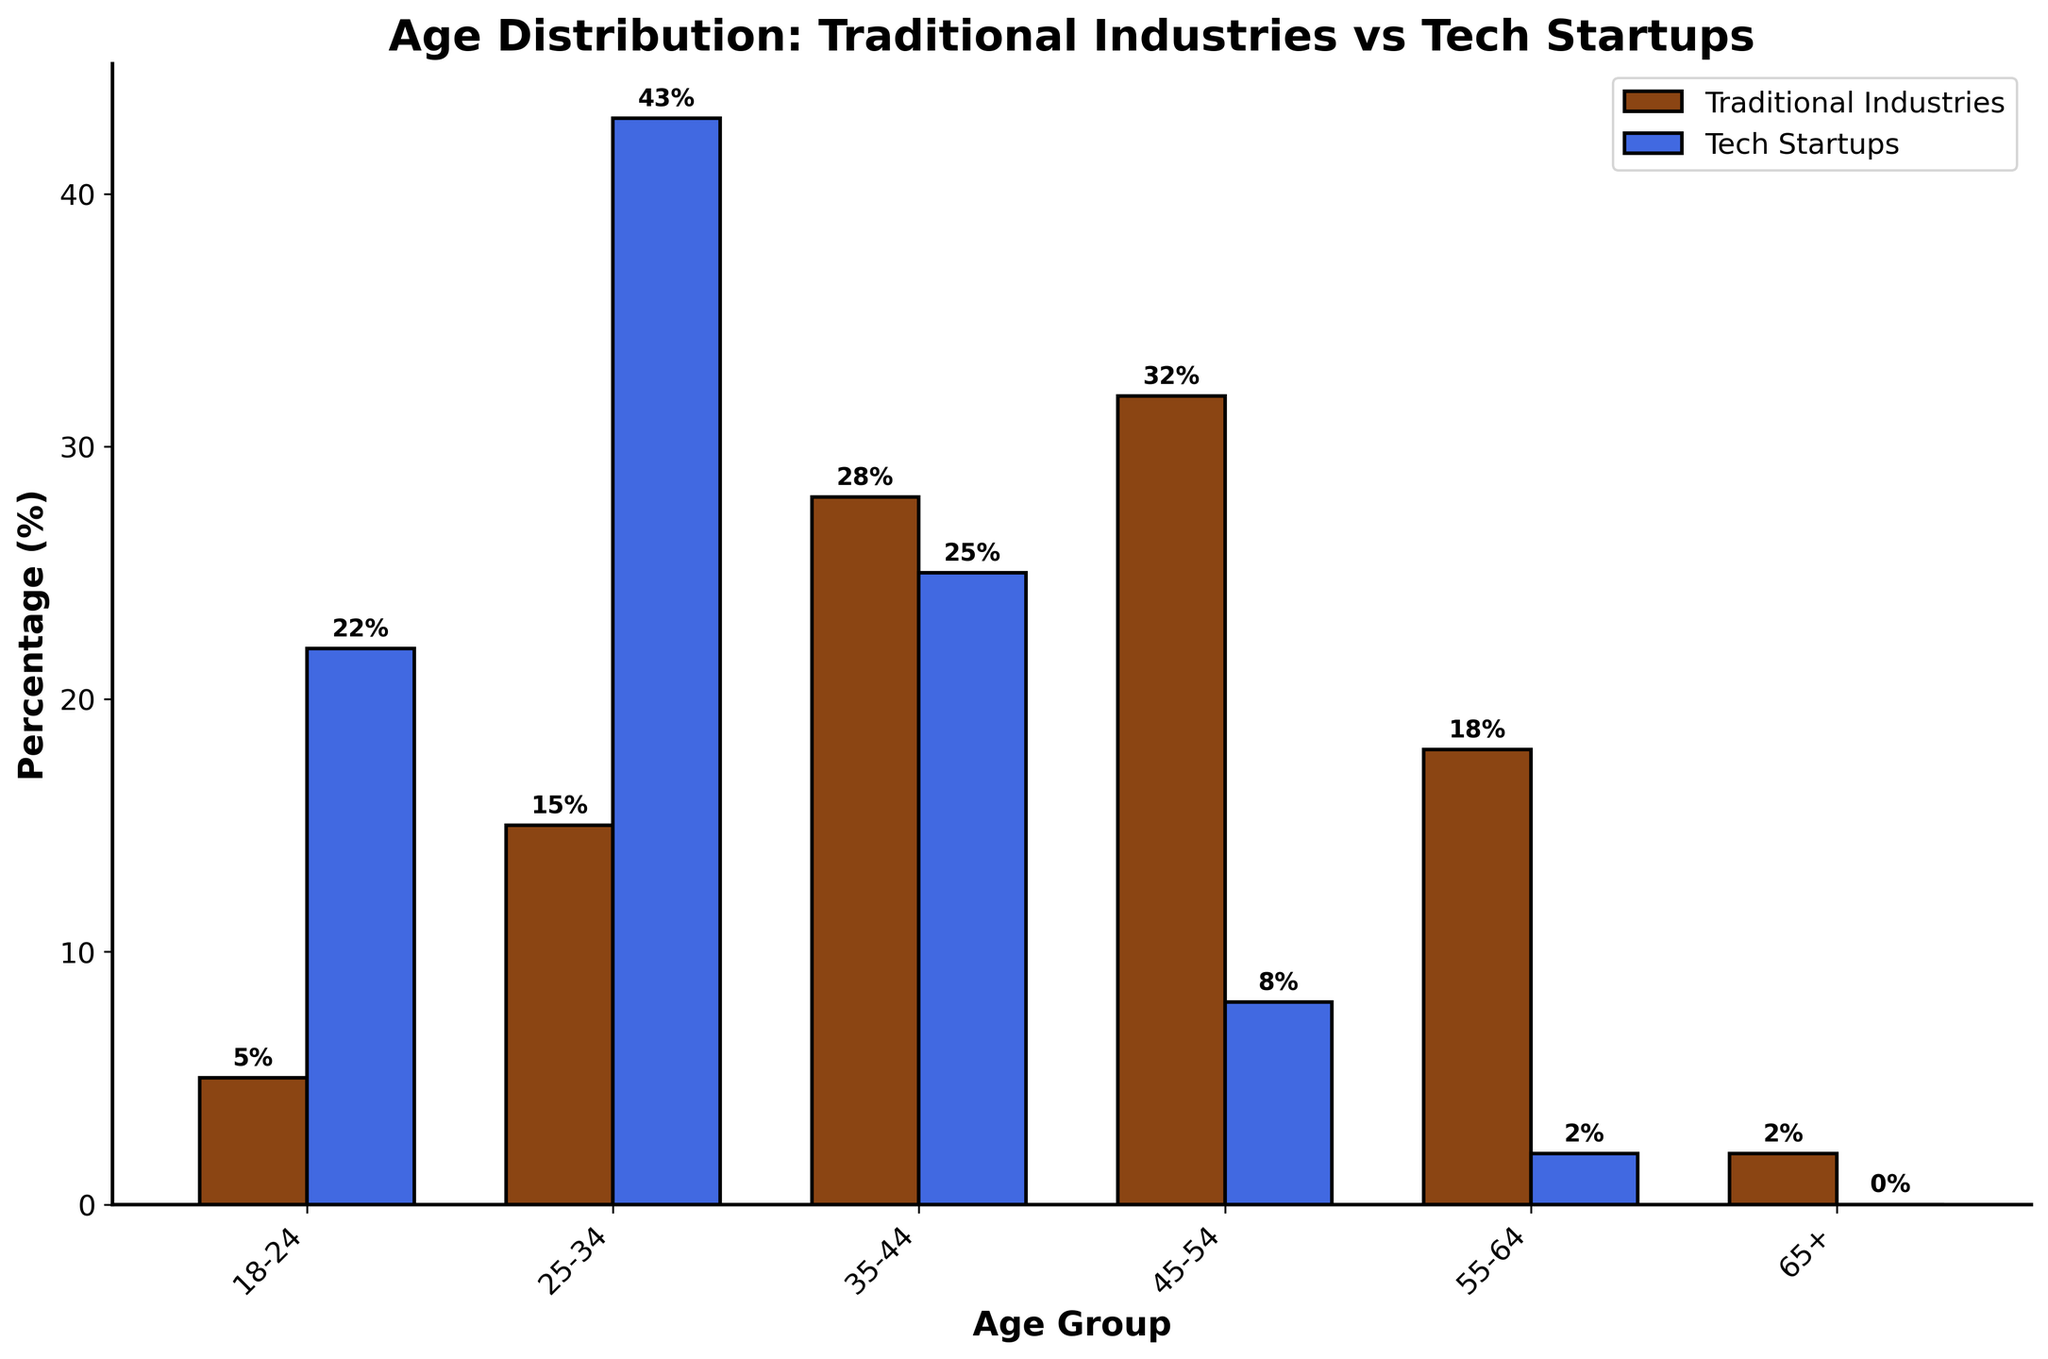Which age group has the highest percentage in traditional industries? The bar for the 45-54 age group is the tallest among the 'Traditional Industries' bars, which indicates the highest percentage.
Answer: 45-54 Which age group has the lowest percentage in tech startups? The bar for the 65+ age group is the shortest among the 'Tech Startups' bars, indicating the lowest percentage.
Answer: 65+ How does the percentage of employees aged 25-34 in tech startups compare to traditional industries? The percentage of employees aged 25-34 in tech startups (43%) is significantly higher than in traditional industries (15%). The bar for tech startups is much taller for this age group.
Answer: Higher What is the total percentage of employees aged 35-44 and 55-64 in traditional industries? For traditional industries, the percentages for the 35-44 and 55-64 age groups are 28% and 18% respectively. Summing these gives 28 + 18 = 46%.
Answer: 46% Which age group shows the most significant difference in representation between traditional industries and tech startups? The 45-54 age group shows the most significant difference: 32% in traditional industries versus 8% in tech startups, a difference of 24 percentage points.
Answer: 45-54 By how much does the percentage of employees aged 18-24 in tech startups exceed that in traditional industries? The percentage of 18-24 age group in tech startups (22%) exceeds that in traditional industries (5%) by 22 - 5 = 17 percentage points.
Answer: 17 What is the average percentage of employees in the 35-44 age group for both traditional industries and tech startups? For the 35-44 age group, the percentages are 28% for traditional industries and 25% for tech startups. The average is (28 + 25) / 2 = 26.5%.
Answer: 26.5% Which age group has more equal representation between traditional industries and tech startups? The 35-44 age group has the most equal representation, with 28% in traditional industries and 25% in tech startups, showing a small difference of 3 percentage points.
Answer: 35-44 What is the combined percentage of employees aged 18-34 in tech startups? For tech startups, add the percentages of the 18-24 (22%) and 25-34 (43%) age groups. The combined percentage is 22 + 43 = 65%.
Answer: 65% What is the difference in percentage for the 55-64 age group between traditional industries and tech startups? The percentage for the 55-64 age group is 18% in traditional industries and 2% in tech startups. The difference is 18 - 2 = 16 percentage points.
Answer: 16 